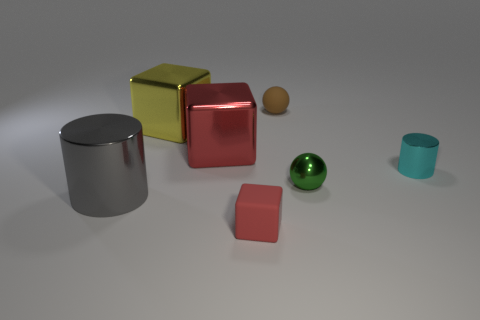Add 3 brown matte balls. How many objects exist? 10 Subtract all cylinders. How many objects are left? 5 Subtract 0 gray cubes. How many objects are left? 7 Subtract all brown things. Subtract all tiny cyan objects. How many objects are left? 5 Add 6 large red cubes. How many large red cubes are left? 7 Add 6 small shiny objects. How many small shiny objects exist? 8 